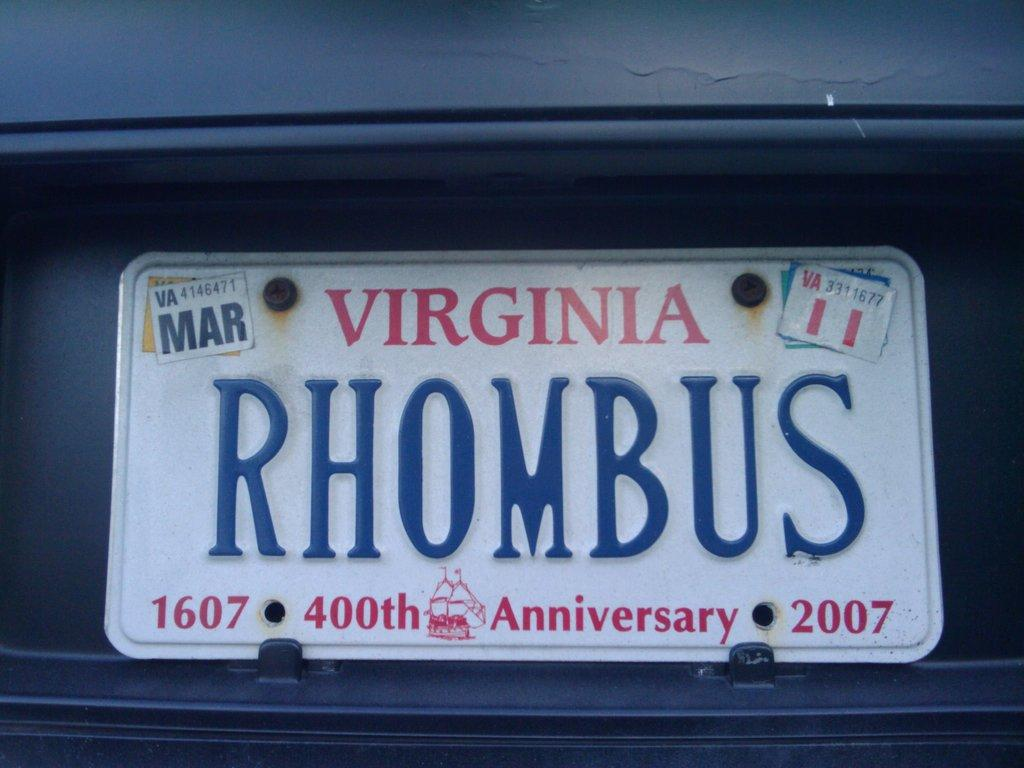<image>
Share a concise interpretation of the image provided. A Virginia license plate with the word rhombus on it 